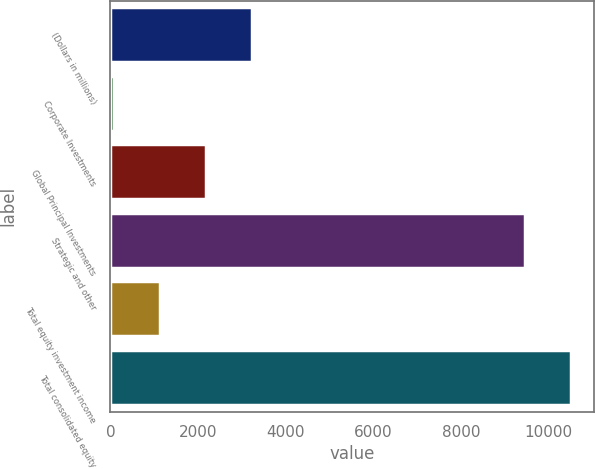<chart> <loc_0><loc_0><loc_500><loc_500><bar_chart><fcel>(Dollars in millions)<fcel>Corporate Investments<fcel>Global Principal Investments<fcel>Strategic and other<fcel>Total equity investment income<fcel>Total consolidated equity<nl><fcel>3238.3<fcel>88<fcel>2188.2<fcel>9455<fcel>1138.1<fcel>10505.1<nl></chart> 